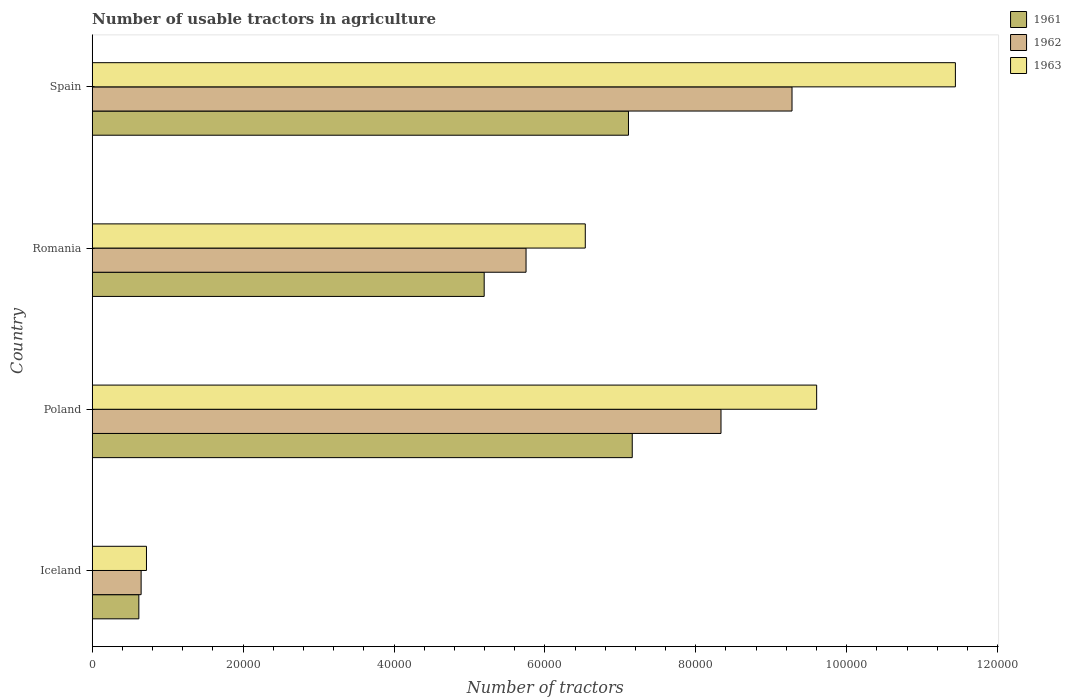How many different coloured bars are there?
Your answer should be compact. 3. How many groups of bars are there?
Offer a very short reply. 4. Are the number of bars per tick equal to the number of legend labels?
Keep it short and to the point. Yes. How many bars are there on the 1st tick from the top?
Your response must be concise. 3. What is the label of the 3rd group of bars from the top?
Offer a terse response. Poland. What is the number of usable tractors in agriculture in 1962 in Spain?
Your answer should be compact. 9.28e+04. Across all countries, what is the maximum number of usable tractors in agriculture in 1963?
Offer a terse response. 1.14e+05. Across all countries, what is the minimum number of usable tractors in agriculture in 1963?
Provide a short and direct response. 7187. In which country was the number of usable tractors in agriculture in 1963 maximum?
Provide a succinct answer. Spain. In which country was the number of usable tractors in agriculture in 1963 minimum?
Provide a succinct answer. Iceland. What is the total number of usable tractors in agriculture in 1961 in the graph?
Provide a short and direct response. 2.01e+05. What is the difference between the number of usable tractors in agriculture in 1961 in Poland and that in Romania?
Ensure brevity in your answer.  1.96e+04. What is the difference between the number of usable tractors in agriculture in 1962 in Romania and the number of usable tractors in agriculture in 1961 in Spain?
Your answer should be very brief. -1.36e+04. What is the average number of usable tractors in agriculture in 1963 per country?
Make the answer very short. 7.07e+04. What is the difference between the number of usable tractors in agriculture in 1963 and number of usable tractors in agriculture in 1962 in Poland?
Make the answer very short. 1.27e+04. In how many countries, is the number of usable tractors in agriculture in 1963 greater than 80000 ?
Your answer should be very brief. 2. What is the ratio of the number of usable tractors in agriculture in 1961 in Romania to that in Spain?
Provide a short and direct response. 0.73. Is the difference between the number of usable tractors in agriculture in 1963 in Romania and Spain greater than the difference between the number of usable tractors in agriculture in 1962 in Romania and Spain?
Your answer should be very brief. No. What is the difference between the highest and the second highest number of usable tractors in agriculture in 1961?
Offer a terse response. 500. What is the difference between the highest and the lowest number of usable tractors in agriculture in 1961?
Offer a very short reply. 6.54e+04. What does the 3rd bar from the bottom in Romania represents?
Provide a succinct answer. 1963. Is it the case that in every country, the sum of the number of usable tractors in agriculture in 1962 and number of usable tractors in agriculture in 1963 is greater than the number of usable tractors in agriculture in 1961?
Provide a short and direct response. Yes. How many bars are there?
Your response must be concise. 12. Are all the bars in the graph horizontal?
Give a very brief answer. Yes. How many countries are there in the graph?
Provide a short and direct response. 4. What is the difference between two consecutive major ticks on the X-axis?
Make the answer very short. 2.00e+04. Does the graph contain any zero values?
Your answer should be very brief. No. Does the graph contain grids?
Ensure brevity in your answer.  No. Where does the legend appear in the graph?
Offer a very short reply. Top right. How are the legend labels stacked?
Provide a succinct answer. Vertical. What is the title of the graph?
Provide a succinct answer. Number of usable tractors in agriculture. Does "1968" appear as one of the legend labels in the graph?
Your answer should be very brief. No. What is the label or title of the X-axis?
Make the answer very short. Number of tractors. What is the Number of tractors in 1961 in Iceland?
Keep it short and to the point. 6177. What is the Number of tractors in 1962 in Iceland?
Provide a short and direct response. 6479. What is the Number of tractors in 1963 in Iceland?
Offer a terse response. 7187. What is the Number of tractors of 1961 in Poland?
Ensure brevity in your answer.  7.16e+04. What is the Number of tractors in 1962 in Poland?
Keep it short and to the point. 8.33e+04. What is the Number of tractors of 1963 in Poland?
Give a very brief answer. 9.60e+04. What is the Number of tractors of 1961 in Romania?
Your answer should be very brief. 5.20e+04. What is the Number of tractors in 1962 in Romania?
Your answer should be compact. 5.75e+04. What is the Number of tractors of 1963 in Romania?
Offer a very short reply. 6.54e+04. What is the Number of tractors of 1961 in Spain?
Your answer should be compact. 7.11e+04. What is the Number of tractors in 1962 in Spain?
Offer a very short reply. 9.28e+04. What is the Number of tractors of 1963 in Spain?
Provide a short and direct response. 1.14e+05. Across all countries, what is the maximum Number of tractors of 1961?
Provide a succinct answer. 7.16e+04. Across all countries, what is the maximum Number of tractors of 1962?
Offer a terse response. 9.28e+04. Across all countries, what is the maximum Number of tractors of 1963?
Provide a succinct answer. 1.14e+05. Across all countries, what is the minimum Number of tractors of 1961?
Offer a terse response. 6177. Across all countries, what is the minimum Number of tractors of 1962?
Offer a terse response. 6479. Across all countries, what is the minimum Number of tractors in 1963?
Your response must be concise. 7187. What is the total Number of tractors of 1961 in the graph?
Your response must be concise. 2.01e+05. What is the total Number of tractors in 1962 in the graph?
Make the answer very short. 2.40e+05. What is the total Number of tractors in 1963 in the graph?
Provide a short and direct response. 2.83e+05. What is the difference between the Number of tractors in 1961 in Iceland and that in Poland?
Offer a terse response. -6.54e+04. What is the difference between the Number of tractors in 1962 in Iceland and that in Poland?
Your response must be concise. -7.69e+04. What is the difference between the Number of tractors of 1963 in Iceland and that in Poland?
Provide a short and direct response. -8.88e+04. What is the difference between the Number of tractors in 1961 in Iceland and that in Romania?
Offer a terse response. -4.58e+04. What is the difference between the Number of tractors in 1962 in Iceland and that in Romania?
Make the answer very short. -5.10e+04. What is the difference between the Number of tractors of 1963 in Iceland and that in Romania?
Make the answer very short. -5.82e+04. What is the difference between the Number of tractors in 1961 in Iceland and that in Spain?
Keep it short and to the point. -6.49e+04. What is the difference between the Number of tractors of 1962 in Iceland and that in Spain?
Offer a terse response. -8.63e+04. What is the difference between the Number of tractors of 1963 in Iceland and that in Spain?
Provide a short and direct response. -1.07e+05. What is the difference between the Number of tractors in 1961 in Poland and that in Romania?
Provide a short and direct response. 1.96e+04. What is the difference between the Number of tractors in 1962 in Poland and that in Romania?
Your answer should be very brief. 2.58e+04. What is the difference between the Number of tractors of 1963 in Poland and that in Romania?
Keep it short and to the point. 3.07e+04. What is the difference between the Number of tractors of 1961 in Poland and that in Spain?
Keep it short and to the point. 500. What is the difference between the Number of tractors of 1962 in Poland and that in Spain?
Your answer should be compact. -9414. What is the difference between the Number of tractors in 1963 in Poland and that in Spain?
Offer a very short reply. -1.84e+04. What is the difference between the Number of tractors of 1961 in Romania and that in Spain?
Provide a short and direct response. -1.91e+04. What is the difference between the Number of tractors of 1962 in Romania and that in Spain?
Your answer should be compact. -3.53e+04. What is the difference between the Number of tractors of 1963 in Romania and that in Spain?
Your answer should be very brief. -4.91e+04. What is the difference between the Number of tractors of 1961 in Iceland and the Number of tractors of 1962 in Poland?
Provide a succinct answer. -7.72e+04. What is the difference between the Number of tractors of 1961 in Iceland and the Number of tractors of 1963 in Poland?
Provide a succinct answer. -8.98e+04. What is the difference between the Number of tractors in 1962 in Iceland and the Number of tractors in 1963 in Poland?
Offer a terse response. -8.95e+04. What is the difference between the Number of tractors of 1961 in Iceland and the Number of tractors of 1962 in Romania?
Offer a terse response. -5.13e+04. What is the difference between the Number of tractors in 1961 in Iceland and the Number of tractors in 1963 in Romania?
Your answer should be very brief. -5.92e+04. What is the difference between the Number of tractors in 1962 in Iceland and the Number of tractors in 1963 in Romania?
Your response must be concise. -5.89e+04. What is the difference between the Number of tractors of 1961 in Iceland and the Number of tractors of 1962 in Spain?
Provide a succinct answer. -8.66e+04. What is the difference between the Number of tractors in 1961 in Iceland and the Number of tractors in 1963 in Spain?
Offer a terse response. -1.08e+05. What is the difference between the Number of tractors of 1962 in Iceland and the Number of tractors of 1963 in Spain?
Provide a succinct answer. -1.08e+05. What is the difference between the Number of tractors in 1961 in Poland and the Number of tractors in 1962 in Romania?
Give a very brief answer. 1.41e+04. What is the difference between the Number of tractors in 1961 in Poland and the Number of tractors in 1963 in Romania?
Provide a succinct answer. 6226. What is the difference between the Number of tractors of 1962 in Poland and the Number of tractors of 1963 in Romania?
Offer a terse response. 1.80e+04. What is the difference between the Number of tractors of 1961 in Poland and the Number of tractors of 1962 in Spain?
Make the answer very short. -2.12e+04. What is the difference between the Number of tractors of 1961 in Poland and the Number of tractors of 1963 in Spain?
Your answer should be very brief. -4.28e+04. What is the difference between the Number of tractors in 1962 in Poland and the Number of tractors in 1963 in Spain?
Ensure brevity in your answer.  -3.11e+04. What is the difference between the Number of tractors in 1961 in Romania and the Number of tractors in 1962 in Spain?
Your answer should be compact. -4.08e+04. What is the difference between the Number of tractors in 1961 in Romania and the Number of tractors in 1963 in Spain?
Provide a succinct answer. -6.25e+04. What is the difference between the Number of tractors in 1962 in Romania and the Number of tractors in 1963 in Spain?
Keep it short and to the point. -5.69e+04. What is the average Number of tractors in 1961 per country?
Provide a succinct answer. 5.02e+04. What is the average Number of tractors in 1962 per country?
Your answer should be very brief. 6.00e+04. What is the average Number of tractors of 1963 per country?
Your answer should be very brief. 7.07e+04. What is the difference between the Number of tractors of 1961 and Number of tractors of 1962 in Iceland?
Your answer should be very brief. -302. What is the difference between the Number of tractors of 1961 and Number of tractors of 1963 in Iceland?
Provide a succinct answer. -1010. What is the difference between the Number of tractors of 1962 and Number of tractors of 1963 in Iceland?
Provide a succinct answer. -708. What is the difference between the Number of tractors in 1961 and Number of tractors in 1962 in Poland?
Your answer should be very brief. -1.18e+04. What is the difference between the Number of tractors in 1961 and Number of tractors in 1963 in Poland?
Keep it short and to the point. -2.44e+04. What is the difference between the Number of tractors in 1962 and Number of tractors in 1963 in Poland?
Offer a very short reply. -1.27e+04. What is the difference between the Number of tractors in 1961 and Number of tractors in 1962 in Romania?
Your answer should be compact. -5548. What is the difference between the Number of tractors of 1961 and Number of tractors of 1963 in Romania?
Your response must be concise. -1.34e+04. What is the difference between the Number of tractors in 1962 and Number of tractors in 1963 in Romania?
Make the answer very short. -7851. What is the difference between the Number of tractors of 1961 and Number of tractors of 1962 in Spain?
Your answer should be compact. -2.17e+04. What is the difference between the Number of tractors in 1961 and Number of tractors in 1963 in Spain?
Offer a very short reply. -4.33e+04. What is the difference between the Number of tractors in 1962 and Number of tractors in 1963 in Spain?
Give a very brief answer. -2.17e+04. What is the ratio of the Number of tractors of 1961 in Iceland to that in Poland?
Provide a succinct answer. 0.09. What is the ratio of the Number of tractors in 1962 in Iceland to that in Poland?
Give a very brief answer. 0.08. What is the ratio of the Number of tractors of 1963 in Iceland to that in Poland?
Keep it short and to the point. 0.07. What is the ratio of the Number of tractors in 1961 in Iceland to that in Romania?
Your response must be concise. 0.12. What is the ratio of the Number of tractors of 1962 in Iceland to that in Romania?
Keep it short and to the point. 0.11. What is the ratio of the Number of tractors of 1963 in Iceland to that in Romania?
Offer a very short reply. 0.11. What is the ratio of the Number of tractors in 1961 in Iceland to that in Spain?
Your answer should be very brief. 0.09. What is the ratio of the Number of tractors of 1962 in Iceland to that in Spain?
Your answer should be very brief. 0.07. What is the ratio of the Number of tractors of 1963 in Iceland to that in Spain?
Offer a very short reply. 0.06. What is the ratio of the Number of tractors of 1961 in Poland to that in Romania?
Offer a very short reply. 1.38. What is the ratio of the Number of tractors in 1962 in Poland to that in Romania?
Your response must be concise. 1.45. What is the ratio of the Number of tractors in 1963 in Poland to that in Romania?
Ensure brevity in your answer.  1.47. What is the ratio of the Number of tractors of 1962 in Poland to that in Spain?
Provide a short and direct response. 0.9. What is the ratio of the Number of tractors of 1963 in Poland to that in Spain?
Make the answer very short. 0.84. What is the ratio of the Number of tractors of 1961 in Romania to that in Spain?
Give a very brief answer. 0.73. What is the ratio of the Number of tractors of 1962 in Romania to that in Spain?
Give a very brief answer. 0.62. What is the ratio of the Number of tractors in 1963 in Romania to that in Spain?
Provide a short and direct response. 0.57. What is the difference between the highest and the second highest Number of tractors of 1961?
Ensure brevity in your answer.  500. What is the difference between the highest and the second highest Number of tractors in 1962?
Offer a terse response. 9414. What is the difference between the highest and the second highest Number of tractors in 1963?
Your response must be concise. 1.84e+04. What is the difference between the highest and the lowest Number of tractors in 1961?
Give a very brief answer. 6.54e+04. What is the difference between the highest and the lowest Number of tractors of 1962?
Offer a very short reply. 8.63e+04. What is the difference between the highest and the lowest Number of tractors in 1963?
Make the answer very short. 1.07e+05. 